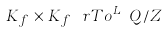Convert formula to latex. <formula><loc_0><loc_0><loc_500><loc_500>K _ { f } \times K _ { f } \ r T o ^ { L _ { f } } Q / Z</formula> 